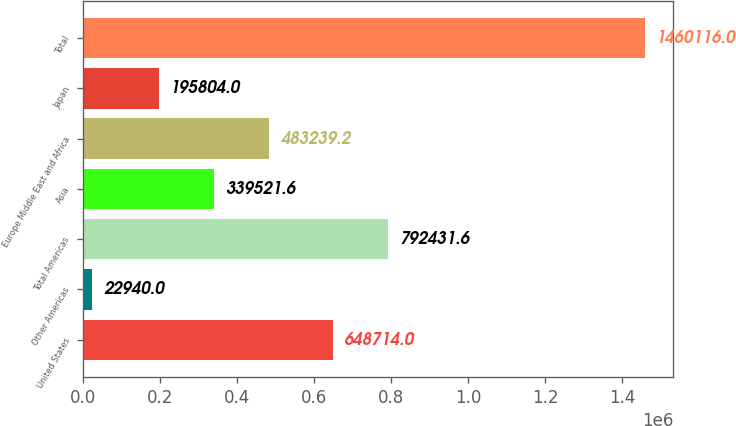Convert chart. <chart><loc_0><loc_0><loc_500><loc_500><bar_chart><fcel>United States<fcel>Other Americas<fcel>Total Americas<fcel>Asia<fcel>Europe Middle East and Africa<fcel>Japan<fcel>Total<nl><fcel>648714<fcel>22940<fcel>792432<fcel>339522<fcel>483239<fcel>195804<fcel>1.46012e+06<nl></chart> 